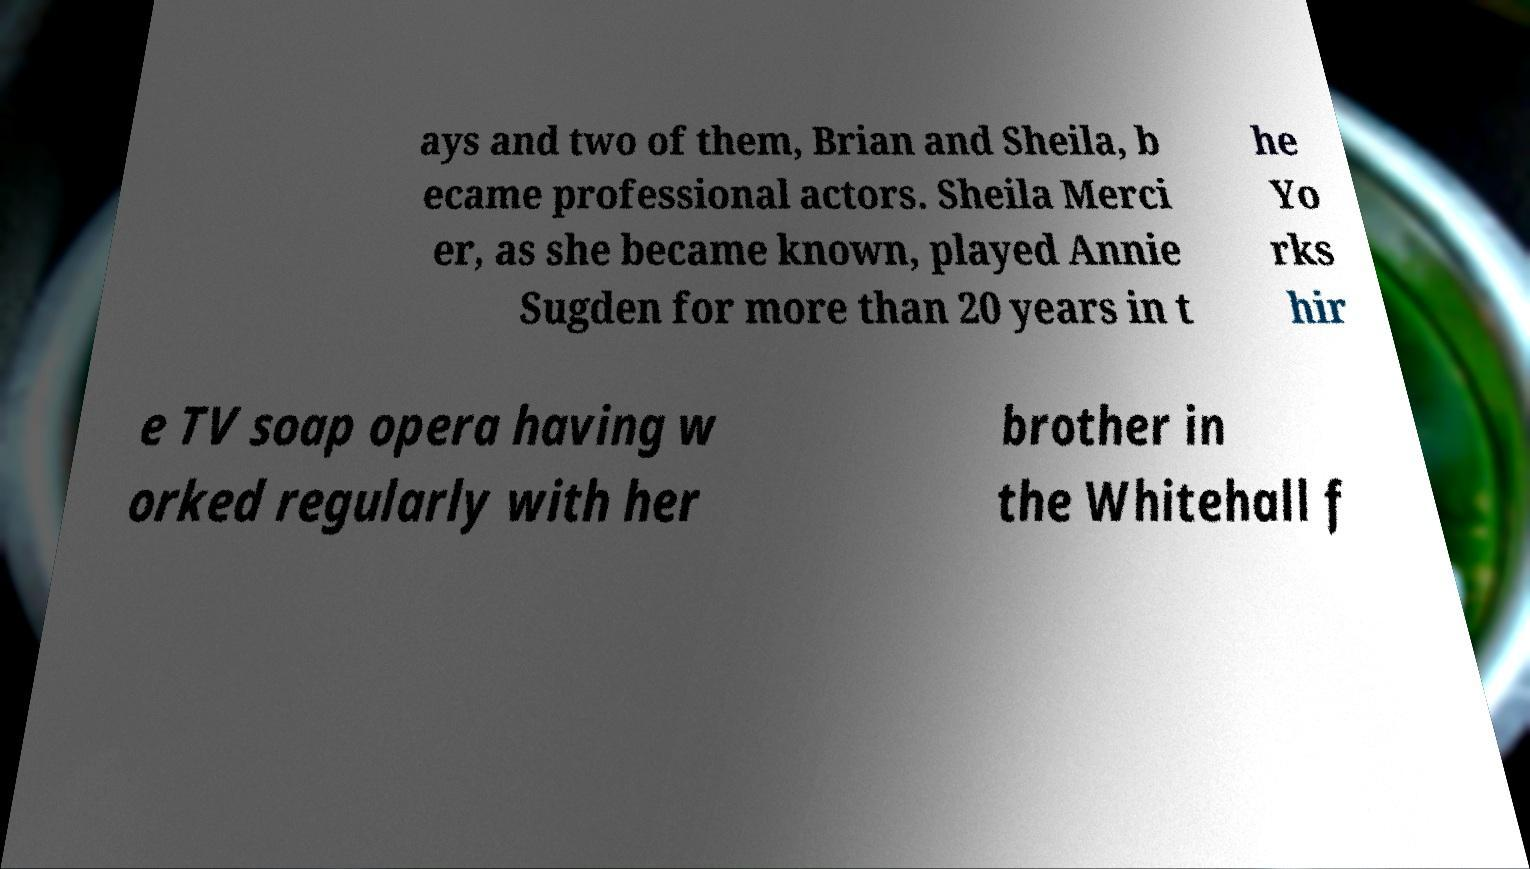Could you extract and type out the text from this image? ays and two of them, Brian and Sheila, b ecame professional actors. Sheila Merci er, as she became known, played Annie Sugden for more than 20 years in t he Yo rks hir e TV soap opera having w orked regularly with her brother in the Whitehall f 